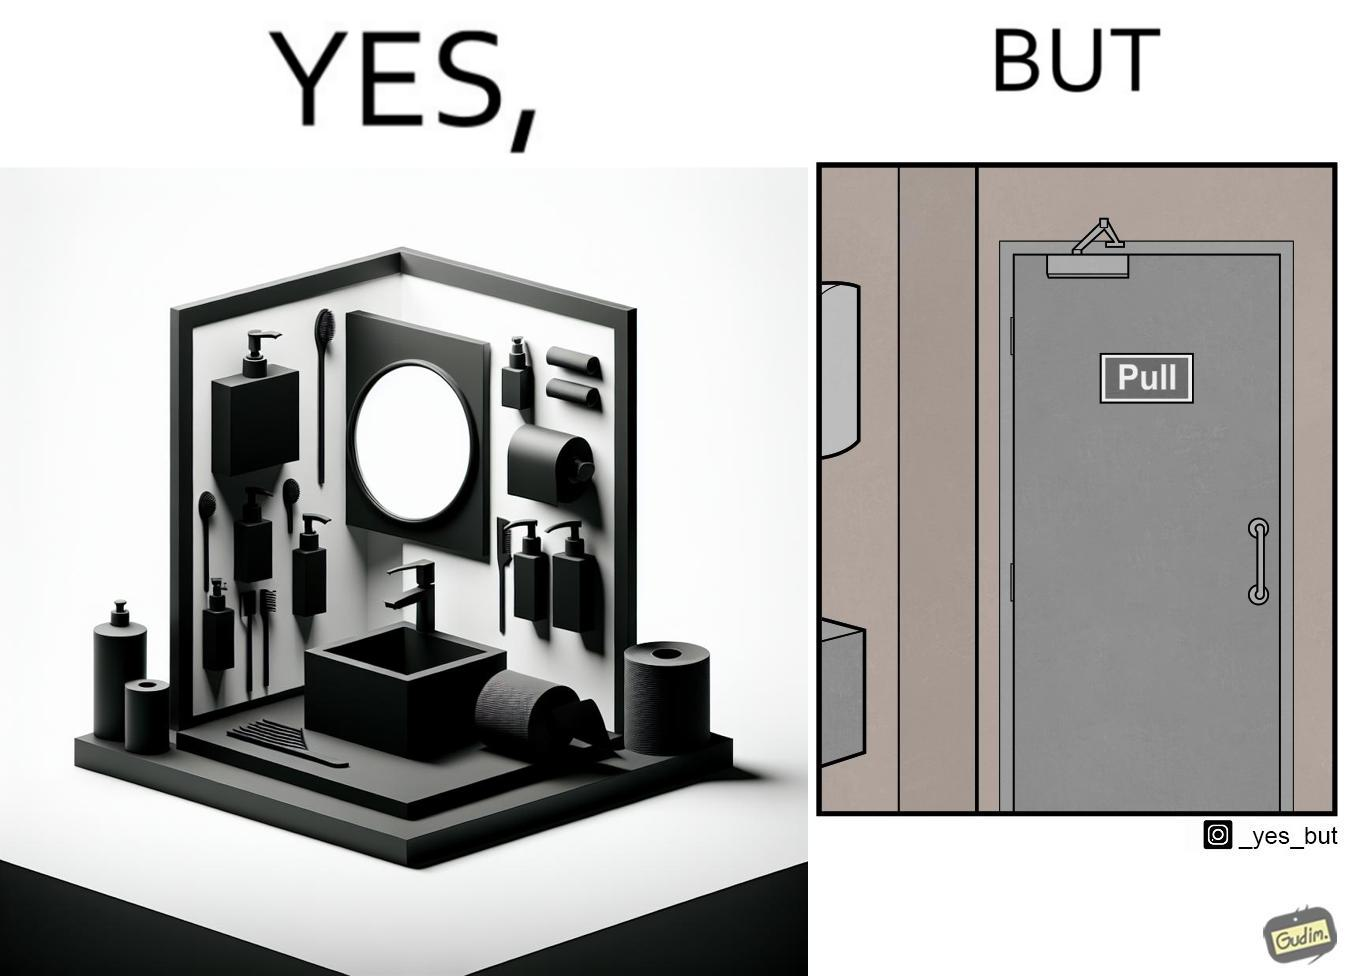Explain why this image is satirical. The image is ironic, because in the first image in the bathroom there are so many things to clean hands around the basin but in the same bathroom people have to open the doors by hand which can easily spread the germs or bacteria even after times of hand cleaning as there is no way to open it without hands 